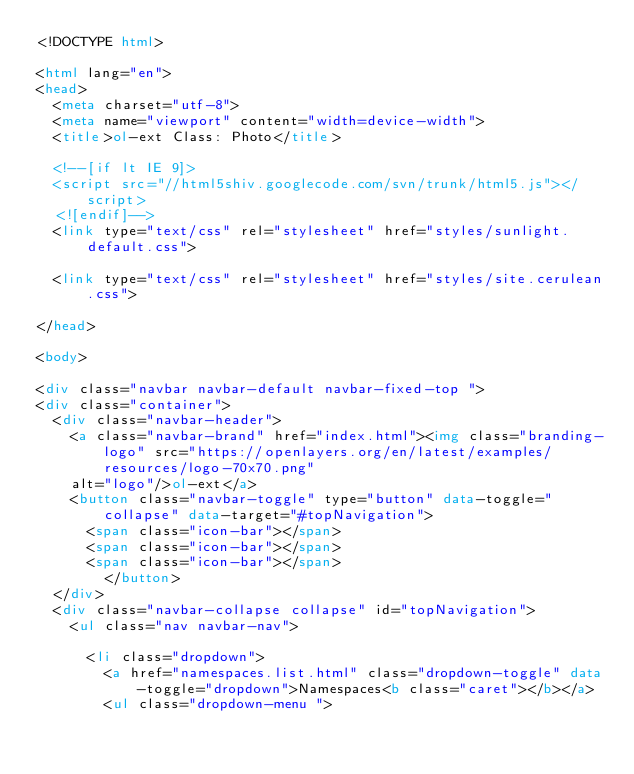<code> <loc_0><loc_0><loc_500><loc_500><_HTML_><!DOCTYPE html>

<html lang="en">
<head>
	<meta charset="utf-8">
	<meta name="viewport" content="width=device-width">
	<title>ol-ext Class: Photo</title>

	<!--[if lt IE 9]>
	<script src="//html5shiv.googlecode.com/svn/trunk/html5.js"></script>
	<![endif]-->
	<link type="text/css" rel="stylesheet" href="styles/sunlight.default.css">

	<link type="text/css" rel="stylesheet" href="styles/site.cerulean.css">

</head>

<body>

<div class="navbar navbar-default navbar-fixed-top ">
<div class="container">
	<div class="navbar-header">
		<a class="navbar-brand" href="index.html"><img class="branding-logo" src="https://openlayers.org/en/latest/examples/resources/logo-70x70.png"
		alt="logo"/>ol-ext</a>
		<button class="navbar-toggle" type="button" data-toggle="collapse" data-target="#topNavigation">
			<span class="icon-bar"></span>
			<span class="icon-bar"></span>
			<span class="icon-bar"></span>
        </button>
	</div>
	<div class="navbar-collapse collapse" id="topNavigation">
		<ul class="nav navbar-nav">
			
			<li class="dropdown">
				<a href="namespaces.list.html" class="dropdown-toggle" data-toggle="dropdown">Namespaces<b class="caret"></b></a>
				<ul class="dropdown-menu "></code> 